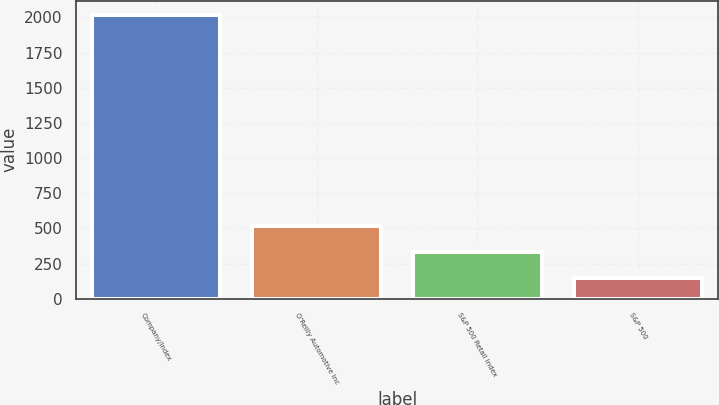<chart> <loc_0><loc_0><loc_500><loc_500><bar_chart><fcel>Company/Index<fcel>O'Reilly Automotive Inc<fcel>S&P 500 Retail Index<fcel>S&P 500<nl><fcel>2017<fcel>519.4<fcel>332.2<fcel>145<nl></chart> 